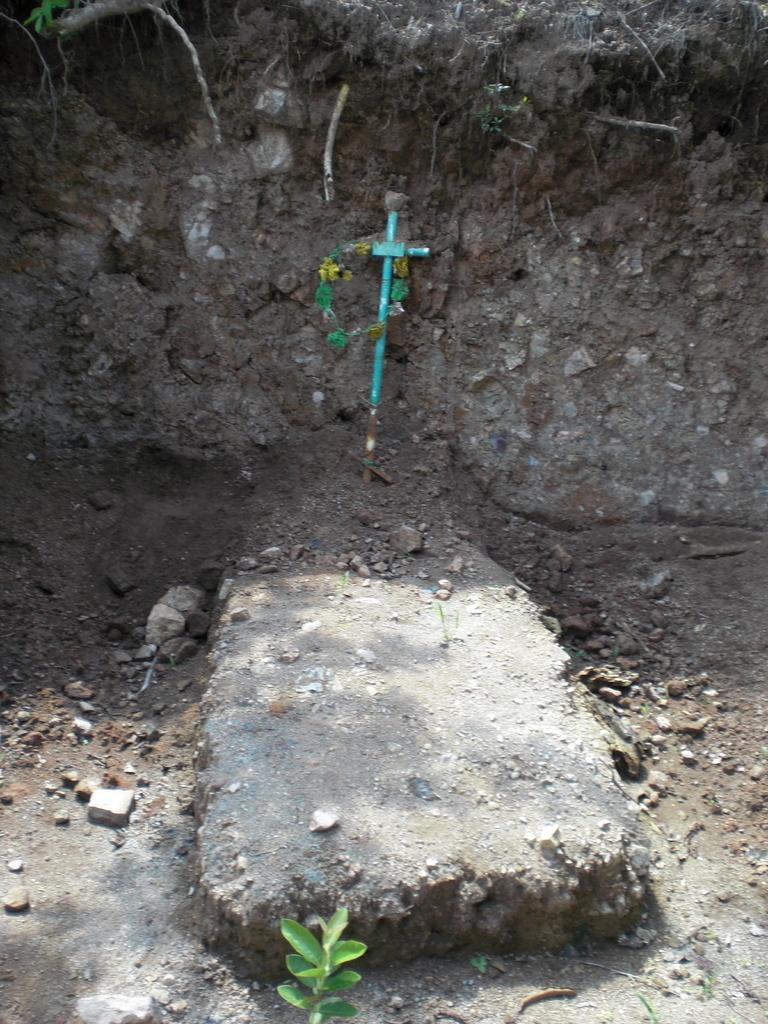What is the main subject of the image? There is a grave in the image. What can be seen near the grave? There is mud near the grave. What type of plant is present in the image? There is a plant in the image. What is the color of the plant's leaves? The plant has green leaves. Can you hear the voice of the person buried in the grave in the image? There is no voice present in the image, as it is a photograph and cannot capture sound. 